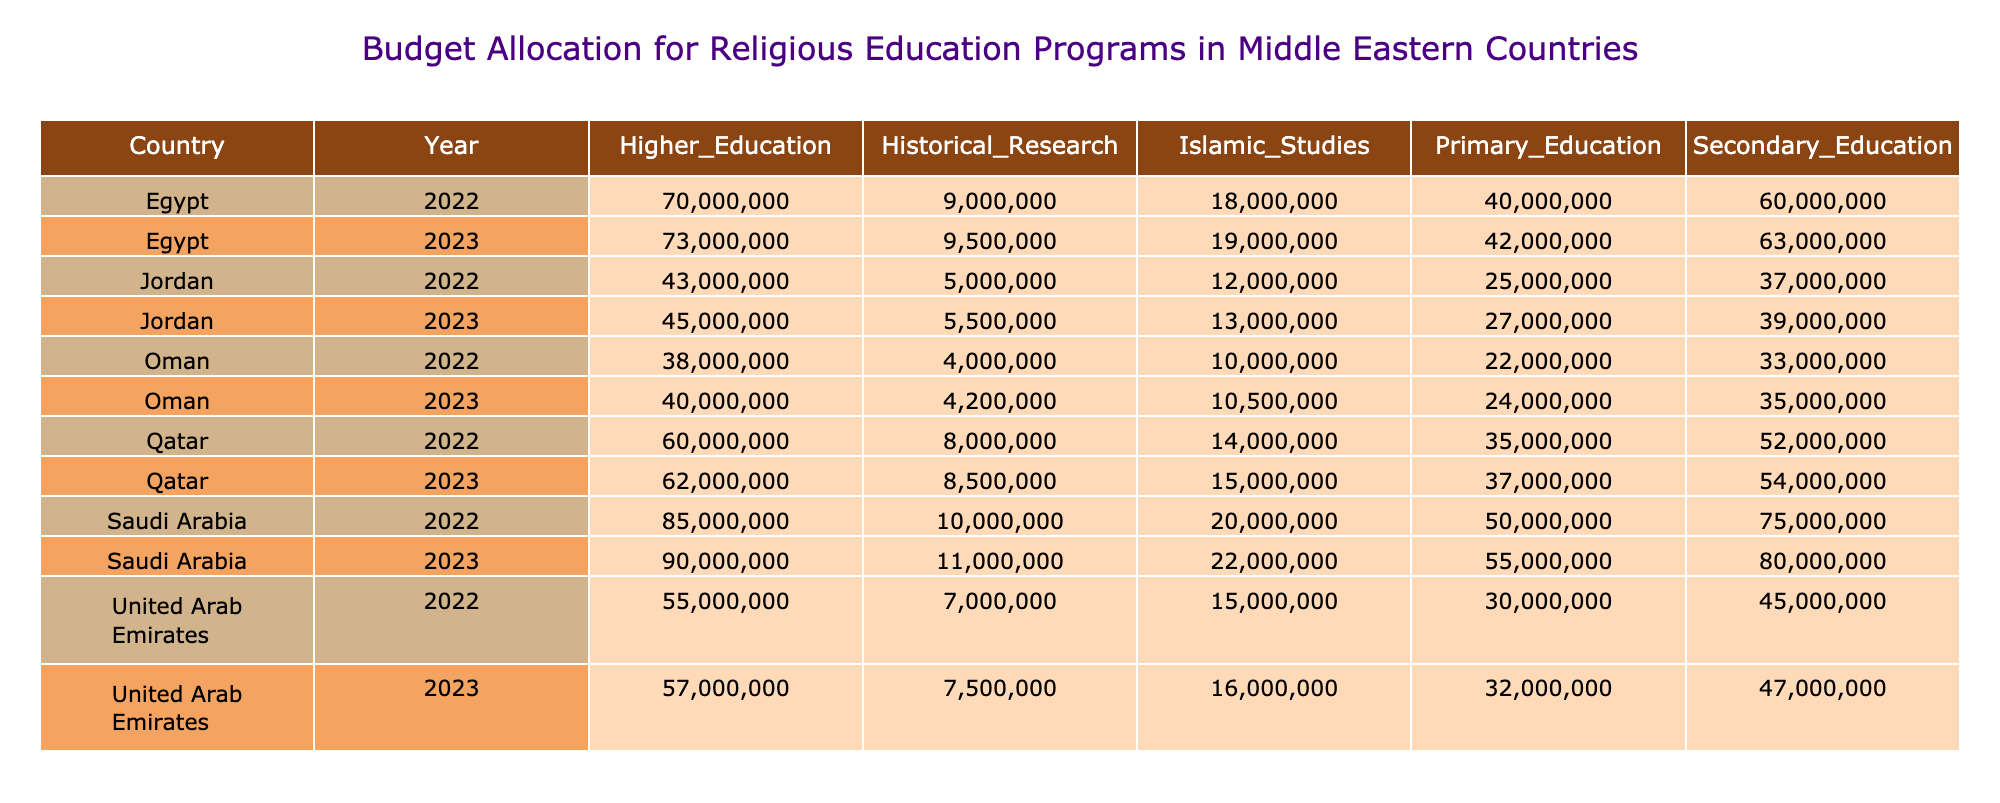What is the budget for Islamic Studies in Egypt for the year 2023? In the table, I check the row for Egypt and the column for the year 2023 to find the value. The budget allocated for Islamic Studies in Egypt in 2023 is 19000000.
Answer: 19000000 Which country had the highest budget allocation for Higher Education in 2022? To find this, I compare the values for Higher Education across all countries for the year 2022. Saudi Arabia has the highest allocation at 85000000.
Answer: Saudi Arabia What is the total budget for Secondary Education across all countries in 2023? I need to sum the Secondary Education allocations from each country for the year 2023. The values are: 80000000 (Saudi Arabia) + 47000000 (UAE) + 63000000 (Egypt) + 39000000 (Jordan) + 54000000 (Qatar) + 35000000 (Oman) = 318000000.
Answer: 318000000 Did Jordan's budget allocation for Historical Research increase from 2022 to 2023? I compare the Historical Research allocations for Jordan in both years. In 2022, it was 5000000, and in 2023 it increased to 5500000. Since 5500000 > 5000000, the answer is yes.
Answer: Yes What is the average budget for Primary Education among the listed countries in 2022? To calculate the average, I sum the Primary Education budgets for all countries in 2022: 50000000 + 30000000 + 40000000 + 25000000 + 35000000 + 22000000 = 202000000. Then, I divide by the number of countries (6): 202000000 / 6 = 33666666.67, rounding gives approximately 33666667.
Answer: 33666667 Which two countries had the lowest budget allocation for Higher Education in 2023? I look at the Higher Education budgets for all countries in 2023. The allocations are: 90000000 (Saudi Arabia), 57000000 (UAE), 73000000 (Egypt), 45000000 (Jordan), 62000000 (Qatar), 40000000 (Oman). The lowest values are for Jordan and Oman.
Answer: Jordan and Oman Is the budget for Islamic Studies in the United Arab Emirates higher in 2023 than in 2022? I compare the Islamic Studies budget in UAE for both years. In 2022, the budget was 15000000, and in 2023, it is 16000000. Since 16000000 > 15000000, the answer is yes.
Answer: Yes What was the change in budget for Secondary Education in Qatar from 2022 to 2023? I subtract the Secondary Education budget of 2022 (52000000) from that of 2023 (54000000) to find the change: 54000000 - 52000000 = 2000000, indicating an increase of this amount.
Answer: 2000000 